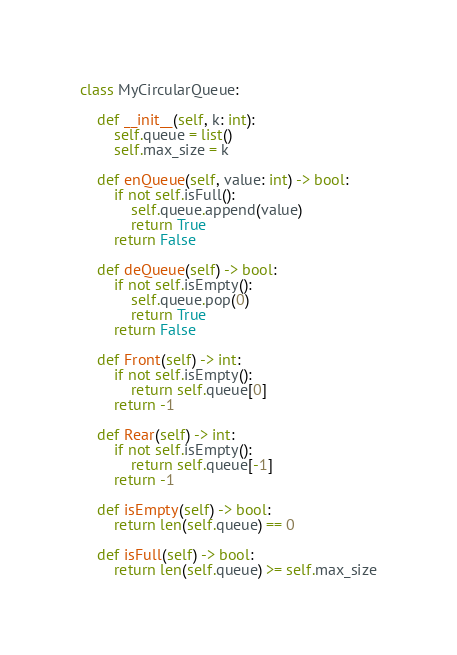<code> <loc_0><loc_0><loc_500><loc_500><_Python_>class MyCircularQueue:
    
    def __init__(self, k: int):
        self.queue = list()
        self.max_size = k
        
    def enQueue(self, value: int) -> bool:
        if not self.isFull():
            self.queue.append(value)
            return True
        return False

    def deQueue(self) -> bool:
        if not self.isEmpty():
            self.queue.pop(0)
            return True
        return False

    def Front(self) -> int:
        if not self.isEmpty():
            return self.queue[0]
        return -1

    def Rear(self) -> int:
        if not self.isEmpty():
            return self.queue[-1]
        return -1

    def isEmpty(self) -> bool:
        return len(self.queue) == 0

    def isFull(self) -> bool:
        return len(self.queue) >= self.max_size
</code> 